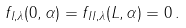<formula> <loc_0><loc_0><loc_500><loc_500>f _ { I , \lambda } ( 0 , \alpha ) = f _ { I I , \lambda } ( L , \alpha ) = 0 \, .</formula> 